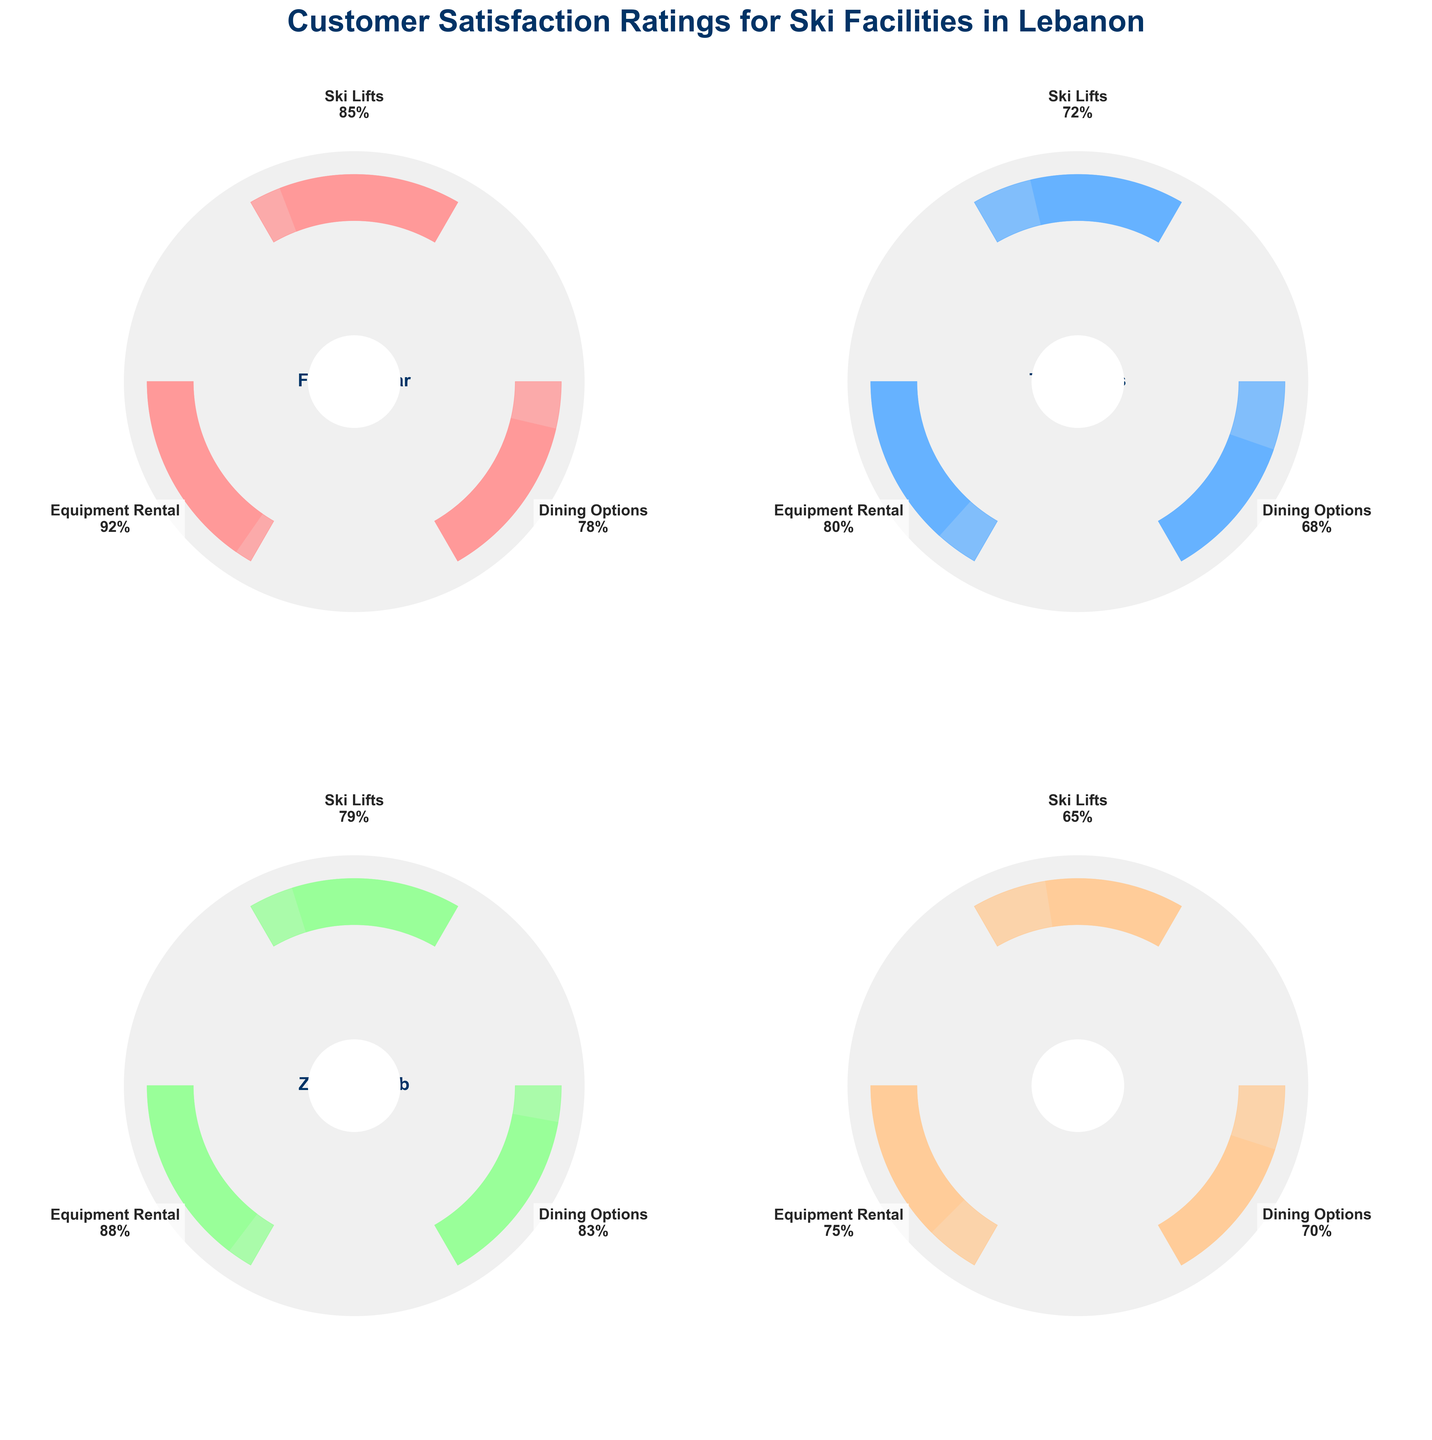What's the highest customer satisfaction rating for any resort amenity? First, identify the satisfaction ratings for all amenities across the resorts: Ski Lifts, Dining Options, Equipment Rental. The highest rating is for Equipment Rental at Faraya Mzaar with 92%.
Answer: 92% Which resort has the lowest customer satisfaction rating for Ski Lifts? Compare the satisfaction ratings for Ski Lifts at all resorts. The lowest rating belongs to Laqlouq at 65%.
Answer: Laqlouq Among the Dining Options, which resort has achieved the highest satisfaction rating? Look at the Dining Options satisfaction ratings for each resort. Zaarour Club has the highest satisfaction with 83%.
Answer: Zaarour Club What's the difference in customer satisfaction for Equipment Rental between the highest and lowest-rated resorts? The highest satisfaction for Equipment Rental is 92% at Faraya Mzaar, and the lowest is 75% at Laqlouq. The difference is 92% - 75% = 17%.
Answer: 17% Which resort shows the most consistent satisfaction ratings across all amenities? Calculate the range (max value - min value) of satisfaction ratings for all amenities in each resort. Faraya Mzaar: 92-78=14, The Cedars: 80-68=12, Zaarour Club: 88-79=9, Laqlouq: 75-65=10. The smallest range is at Zaarour Club.
Answer: Zaarour Club How does the satisfaction rating for Faraya Mzaar's Dining Options compare to The Cedars' Dining Options? Faraya Mzaar's Dining Options have a satisfaction rating of 78%, while The Cedars have 68%. 78% is higher than 68%.
Answer: Faraya Mzaar's Dining Options are higher Which amenity has the lowest average customer satisfaction across all resorts? Calculate the average satisfaction for each amenity: 
- Ski Lifts: (85+72+79+65)/4 = 75.25 
- Dining Options: (78+68+83+70)/4 = 74.75 
- Equipment Rental: (92+80+88+75)/4 = 83.75.
Dining Options has the lowest average with 74.75%.
Answer: Dining Options Which resort appears to need improvement in Dining Options the most, based on customer satisfaction? The Cedars has the lowest satisfaction rating for Dining Options among all resorts with 68%.
Answer: The Cedars 